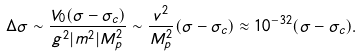<formula> <loc_0><loc_0><loc_500><loc_500>\Delta \sigma \sim \frac { V _ { 0 } ( \sigma - \sigma _ { c } ) } { g ^ { 2 } | m ^ { 2 } | M _ { p } ^ { 2 } } \sim \frac { v ^ { 2 } } { M _ { p } ^ { 2 } } ( \sigma - \sigma _ { c } ) \approx 1 0 ^ { - 3 2 } ( \sigma - \sigma _ { c } ) .</formula> 